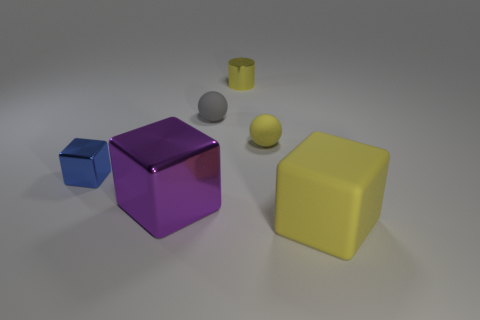Subtract all metal blocks. How many blocks are left? 1 Add 1 small objects. How many objects exist? 7 Subtract all yellow cubes. How many cubes are left? 2 Subtract 1 balls. How many balls are left? 1 Subtract all gray cylinders. How many gray balls are left? 1 Subtract all small yellow matte cubes. Subtract all small yellow objects. How many objects are left? 4 Add 5 big purple shiny blocks. How many big purple shiny blocks are left? 6 Add 1 yellow blocks. How many yellow blocks exist? 2 Subtract 1 blue blocks. How many objects are left? 5 Subtract all balls. How many objects are left? 4 